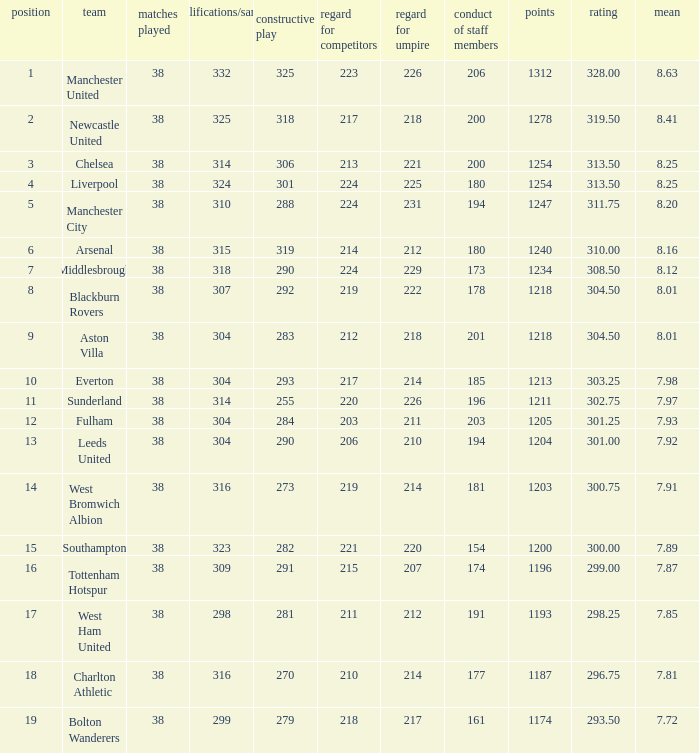Name the pos for west ham united 17.0. 